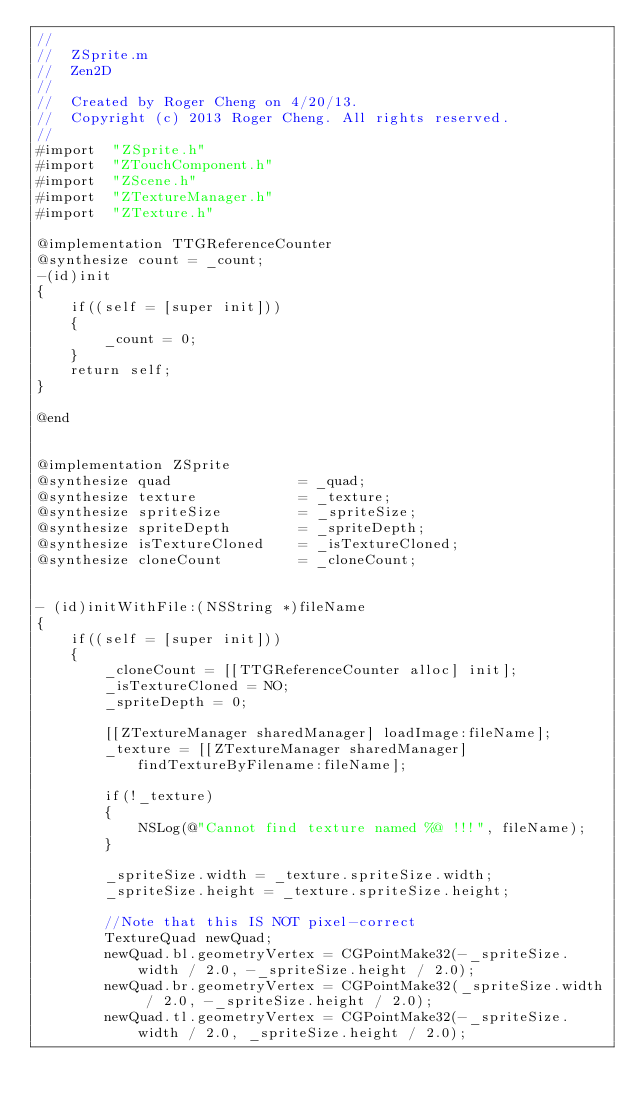<code> <loc_0><loc_0><loc_500><loc_500><_ObjectiveC_>//
//  ZSprite.m
//  Zen2D
//
//  Created by Roger Cheng on 4/20/13.
//  Copyright (c) 2013 Roger Cheng. All rights reserved.
//
#import  "ZSprite.h"
#import  "ZTouchComponent.h"
#import  "ZScene.h"
#import  "ZTextureManager.h"
#import  "ZTexture.h"

@implementation TTGReferenceCounter
@synthesize count = _count;
-(id)init
{
    if((self = [super init]))
    {
        _count = 0;
    }
    return self;
}

@end


@implementation ZSprite
@synthesize quad               = _quad;
@synthesize texture            = _texture;
@synthesize spriteSize         = _spriteSize;
@synthesize spriteDepth        = _spriteDepth;
@synthesize isTextureCloned    = _isTextureCloned;
@synthesize cloneCount         = _cloneCount;


- (id)initWithFile:(NSString *)fileName
{
    if((self = [super init]))
    {
        _cloneCount = [[TTGReferenceCounter alloc] init];
        _isTextureCloned = NO;
        _spriteDepth = 0;
        
        [[ZTextureManager sharedManager] loadImage:fileName];
        _texture = [[ZTextureManager sharedManager] findTextureByFilename:fileName];
        
        if(!_texture)
        {
            NSLog(@"Cannot find texture named %@ !!!", fileName);
        }
        
        _spriteSize.width = _texture.spriteSize.width;
        _spriteSize.height = _texture.spriteSize.height;
        
        //Note that this IS NOT pixel-correct
        TextureQuad newQuad;
        newQuad.bl.geometryVertex = CGPointMake32(-_spriteSize.width / 2.0, -_spriteSize.height / 2.0);
        newQuad.br.geometryVertex = CGPointMake32(_spriteSize.width / 2.0, -_spriteSize.height / 2.0);
        newQuad.tl.geometryVertex = CGPointMake32(-_spriteSize.width / 2.0, _spriteSize.height / 2.0);</code> 